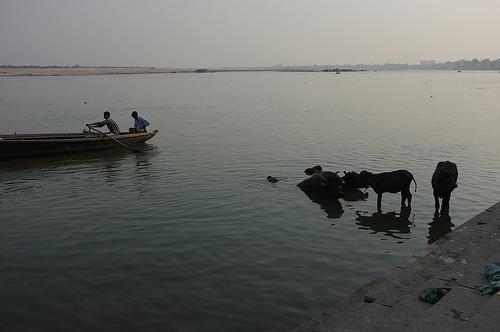How many men are there?
Give a very brief answer. 2. How many cows are in the photo?
Give a very brief answer. 2. 